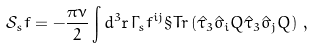<formula> <loc_0><loc_0><loc_500><loc_500>\mathcal { S } _ { s } f = - \frac { \pi \nu } 2 \int d ^ { 3 } \mathbf r \, \Gamma _ { s } f ^ { i j } \S T r \left ( \hat { \tau } _ { 3 } \hat { \sigma } _ { i } Q \hat { \tau } _ { 3 } \hat { \sigma } _ { j } Q \right ) \, ,</formula> 